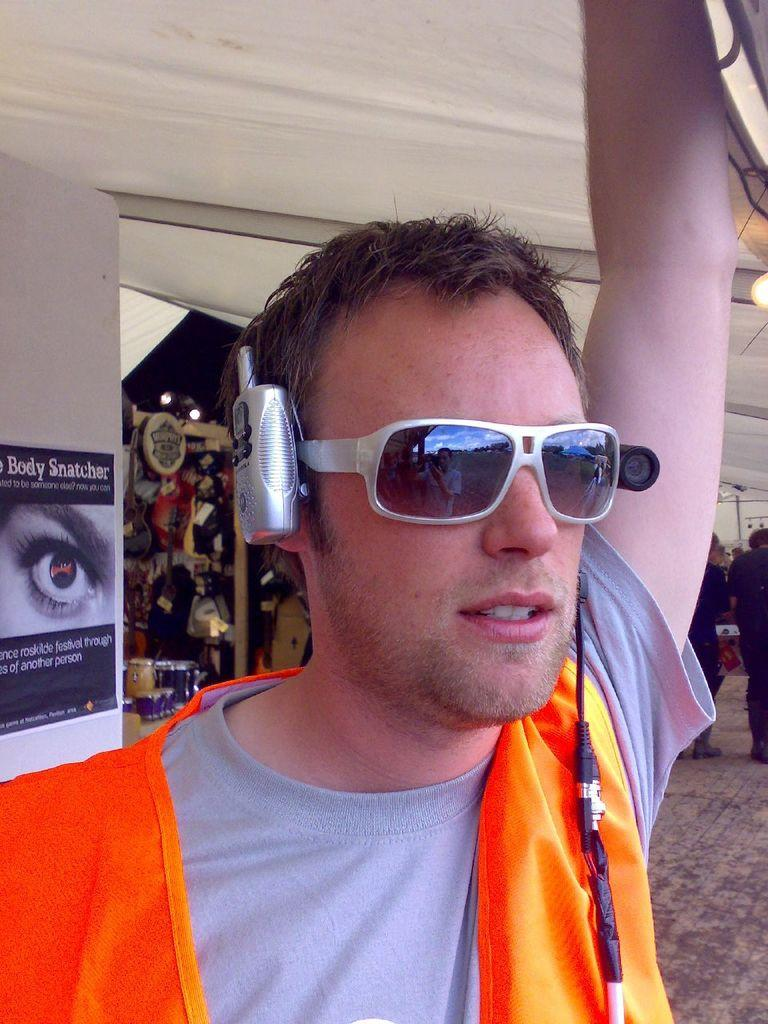What is present in the image? There is a person in the image. Can you describe the person's appearance? The person is wearing spectacles. What can be seen on the wall in the image? There are posters on the wall in the image. What type of lunch is the person eating in the image? There is no indication in the image that the person is eating lunch, so it cannot be determined from the picture. Can you tell me how many horses are visible in the image? There are no horses present in the image. 